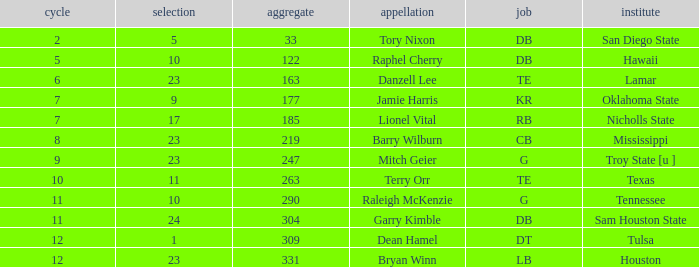How many Picks have a College of hawaii, and an Overall smaller than 122? 0.0. 